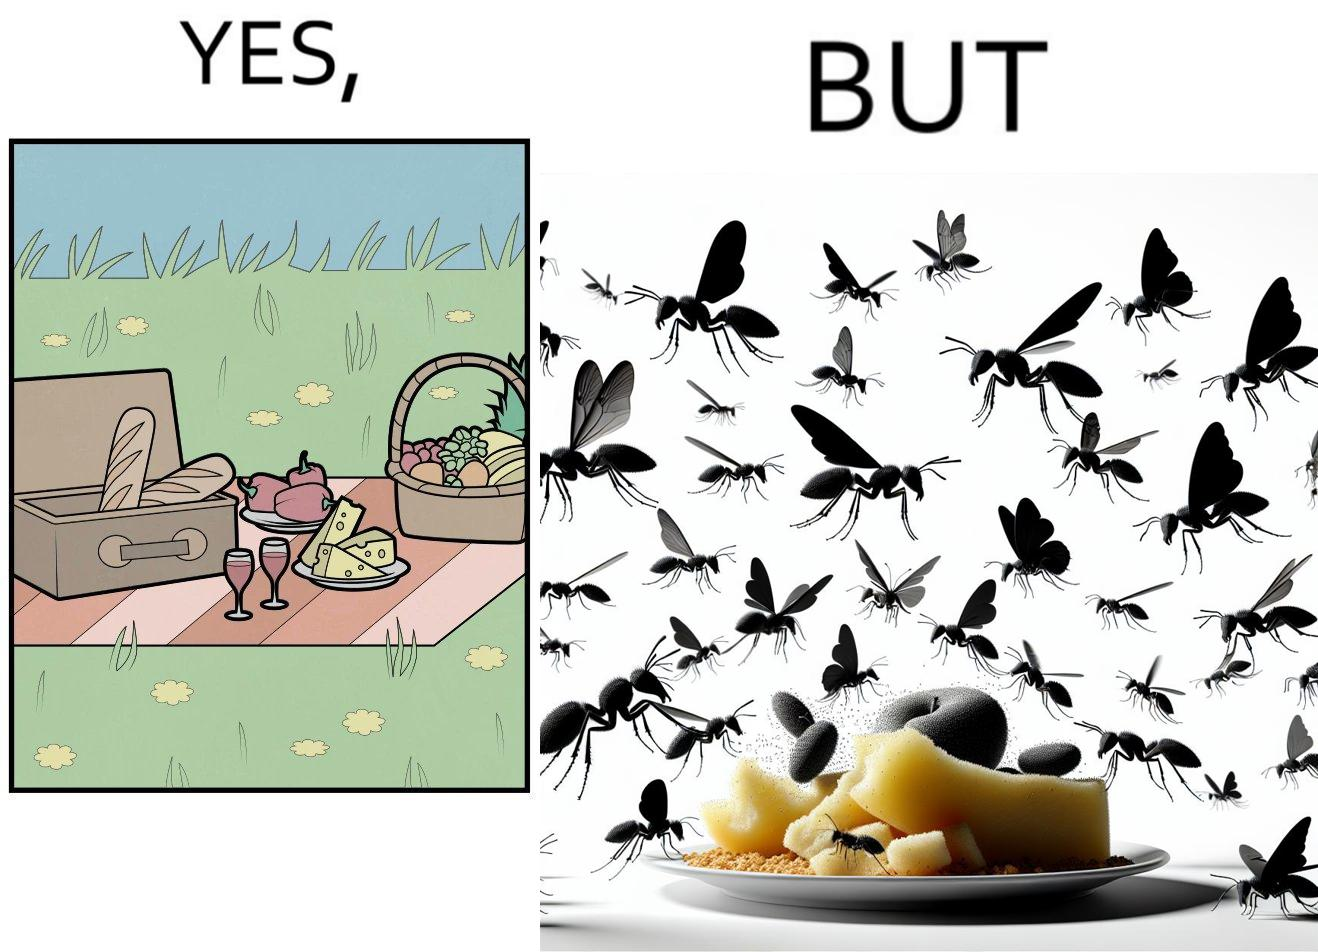What is shown in this image? The Picture shows that although we enjoy food in garden but there are some consequences of eating food in garden. Many bugs and bees are attracted towards our food and make our food sometimes non-eatable. 